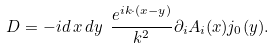Convert formula to latex. <formula><loc_0><loc_0><loc_500><loc_500>D = - i d \, { x } \, d { y } \ \frac { e ^ { i { k \cdot ( x - y ) } } } { k ^ { 2 } } \partial _ { i } A _ { i } ( { x } ) j _ { 0 } ( { y } ) .</formula> 